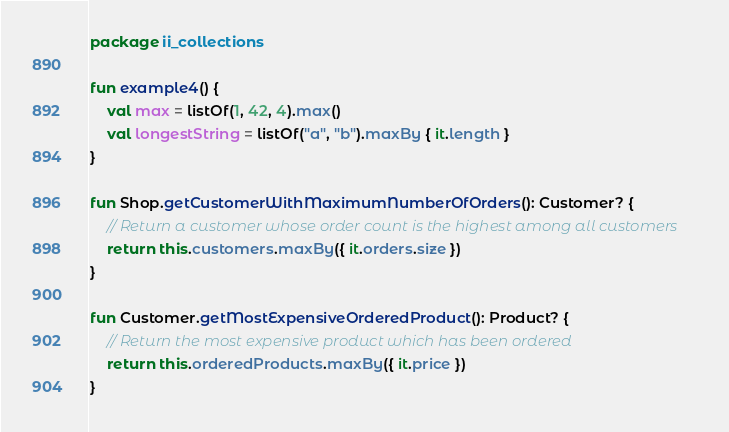<code> <loc_0><loc_0><loc_500><loc_500><_Kotlin_>package ii_collections

fun example4() {
    val max = listOf(1, 42, 4).max()
    val longestString = listOf("a", "b").maxBy { it.length }
}

fun Shop.getCustomerWithMaximumNumberOfOrders(): Customer? {
    // Return a customer whose order count is the highest among all customers
    return this.customers.maxBy({ it.orders.size })
}

fun Customer.getMostExpensiveOrderedProduct(): Product? {
    // Return the most expensive product which has been ordered
    return this.orderedProducts.maxBy({ it.price })
}
</code> 